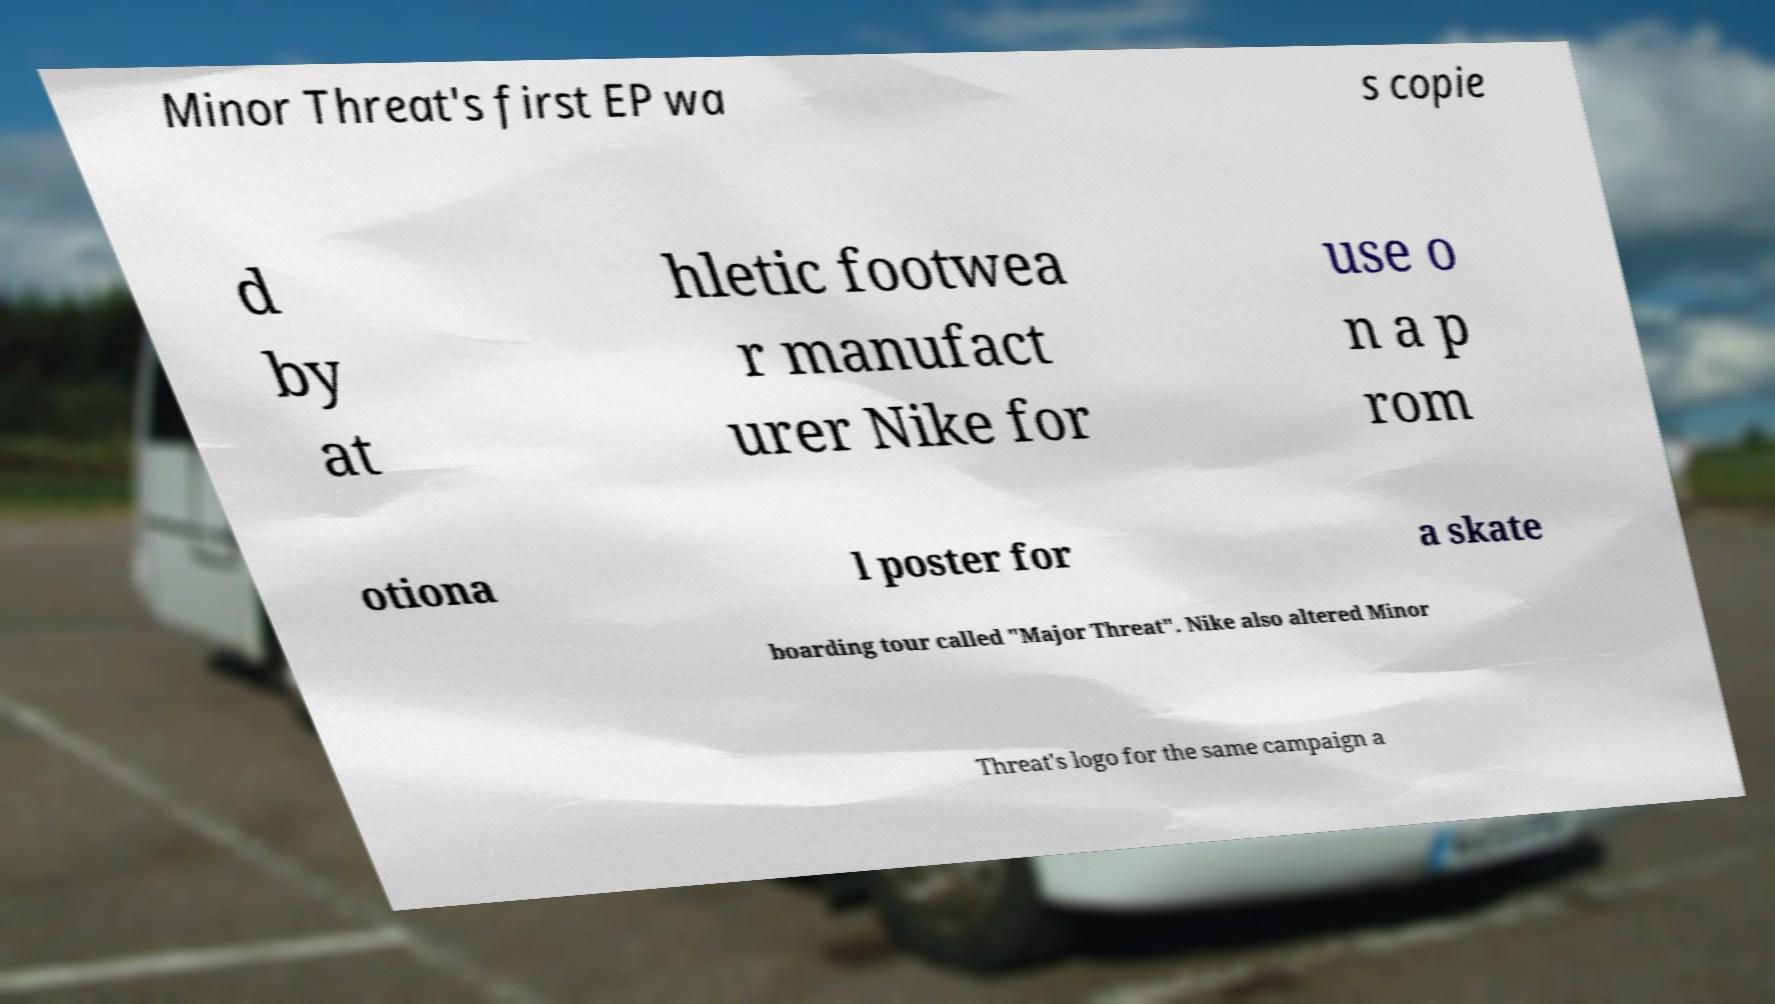Please read and relay the text visible in this image. What does it say? Minor Threat's first EP wa s copie d by at hletic footwea r manufact urer Nike for use o n a p rom otiona l poster for a skate boarding tour called "Major Threat". Nike also altered Minor Threat's logo for the same campaign a 